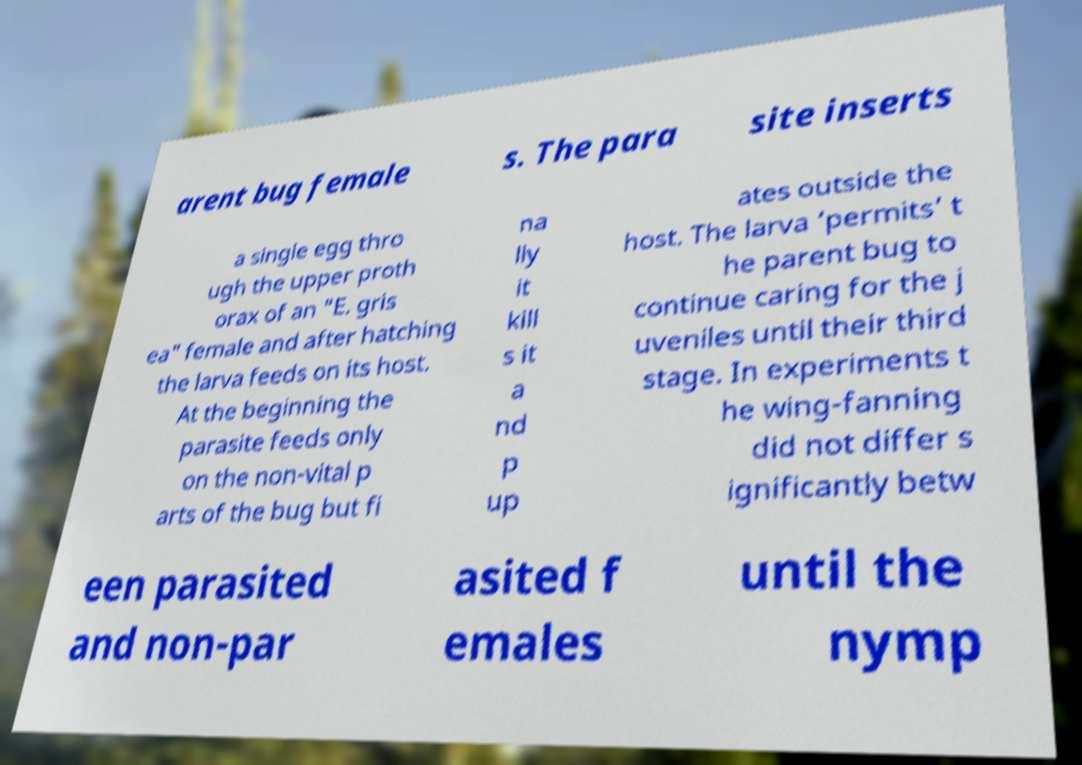What messages or text are displayed in this image? I need them in a readable, typed format. arent bug female s. The para site inserts a single egg thro ugh the upper proth orax of an "E. gris ea" female and after hatching the larva feeds on its host. At the beginning the parasite feeds only on the non-vital p arts of the bug but fi na lly it kill s it a nd p up ates outside the host. The larva ‘permits’ t he parent bug to continue caring for the j uveniles until their third stage. In experiments t he wing-fanning did not differ s ignificantly betw een parasited and non-par asited f emales until the nymp 